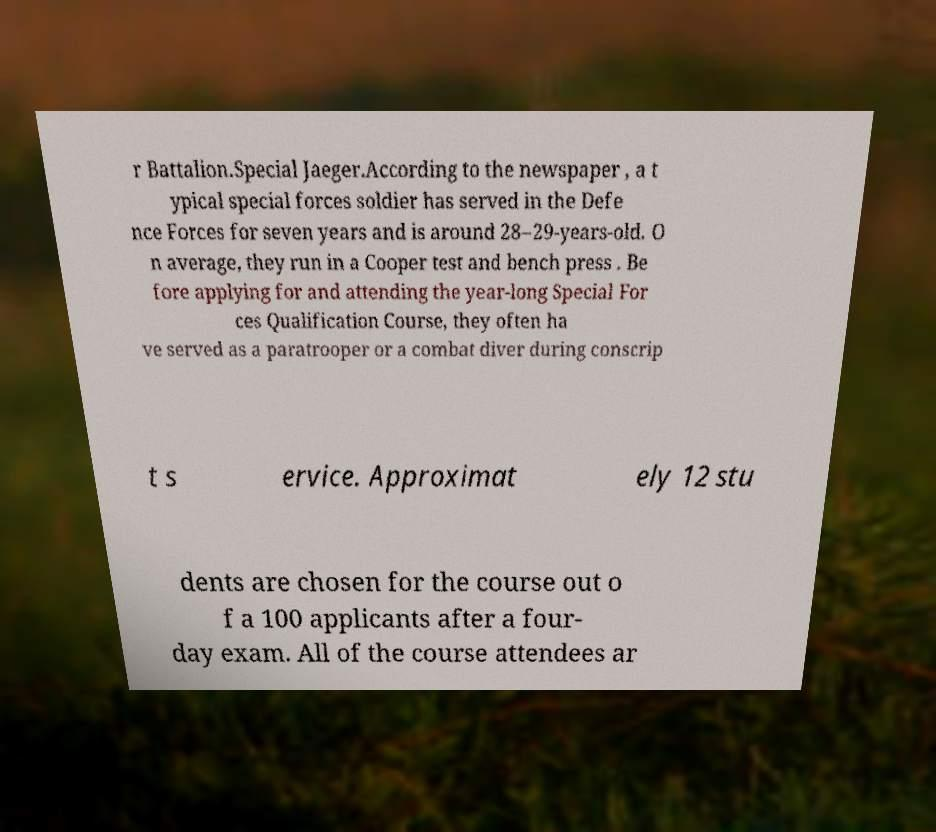Could you extract and type out the text from this image? r Battalion.Special Jaeger.According to the newspaper , a t ypical special forces soldier has served in the Defe nce Forces for seven years and is around 28–29-years-old. O n average, they run in a Cooper test and bench press . Be fore applying for and attending the year-long Special For ces Qualification Course, they often ha ve served as a paratrooper or a combat diver during conscrip t s ervice. Approximat ely 12 stu dents are chosen for the course out o f a 100 applicants after a four- day exam. All of the course attendees ar 